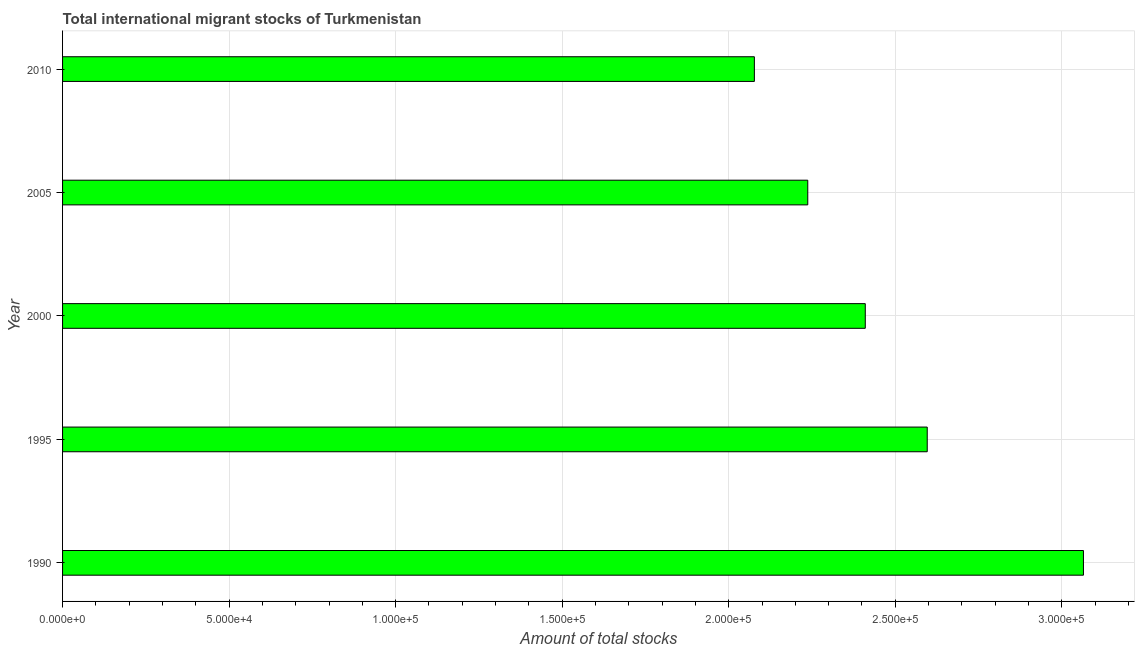Does the graph contain any zero values?
Give a very brief answer. No. What is the title of the graph?
Make the answer very short. Total international migrant stocks of Turkmenistan. What is the label or title of the X-axis?
Provide a short and direct response. Amount of total stocks. What is the label or title of the Y-axis?
Your answer should be compact. Year. What is the total number of international migrant stock in 2000?
Your answer should be very brief. 2.41e+05. Across all years, what is the maximum total number of international migrant stock?
Offer a terse response. 3.06e+05. Across all years, what is the minimum total number of international migrant stock?
Offer a terse response. 2.08e+05. What is the sum of the total number of international migrant stock?
Your answer should be very brief. 1.24e+06. What is the difference between the total number of international migrant stock in 1990 and 2000?
Offer a very short reply. 6.55e+04. What is the average total number of international migrant stock per year?
Your response must be concise. 2.48e+05. What is the median total number of international migrant stock?
Offer a terse response. 2.41e+05. What is the ratio of the total number of international migrant stock in 2000 to that in 2005?
Provide a short and direct response. 1.08. What is the difference between the highest and the second highest total number of international migrant stock?
Your answer should be very brief. 4.69e+04. Is the sum of the total number of international migrant stock in 2000 and 2005 greater than the maximum total number of international migrant stock across all years?
Your answer should be compact. Yes. What is the difference between the highest and the lowest total number of international migrant stock?
Ensure brevity in your answer.  9.88e+04. Are all the bars in the graph horizontal?
Keep it short and to the point. Yes. How many years are there in the graph?
Make the answer very short. 5. What is the difference between two consecutive major ticks on the X-axis?
Your response must be concise. 5.00e+04. Are the values on the major ticks of X-axis written in scientific E-notation?
Offer a very short reply. Yes. What is the Amount of total stocks in 1990?
Provide a succinct answer. 3.06e+05. What is the Amount of total stocks in 1995?
Provide a succinct answer. 2.60e+05. What is the Amount of total stocks of 2000?
Offer a very short reply. 2.41e+05. What is the Amount of total stocks of 2005?
Offer a very short reply. 2.24e+05. What is the Amount of total stocks of 2010?
Provide a succinct answer. 2.08e+05. What is the difference between the Amount of total stocks in 1990 and 1995?
Keep it short and to the point. 4.69e+04. What is the difference between the Amount of total stocks in 1990 and 2000?
Keep it short and to the point. 6.55e+04. What is the difference between the Amount of total stocks in 1990 and 2005?
Give a very brief answer. 8.28e+04. What is the difference between the Amount of total stocks in 1990 and 2010?
Offer a terse response. 9.88e+04. What is the difference between the Amount of total stocks in 1995 and 2000?
Offer a terse response. 1.86e+04. What is the difference between the Amount of total stocks in 1995 and 2005?
Offer a very short reply. 3.59e+04. What is the difference between the Amount of total stocks in 1995 and 2010?
Keep it short and to the point. 5.19e+04. What is the difference between the Amount of total stocks in 2000 and 2005?
Provide a succinct answer. 1.73e+04. What is the difference between the Amount of total stocks in 2000 and 2010?
Keep it short and to the point. 3.33e+04. What is the difference between the Amount of total stocks in 2005 and 2010?
Your answer should be very brief. 1.60e+04. What is the ratio of the Amount of total stocks in 1990 to that in 1995?
Ensure brevity in your answer.  1.18. What is the ratio of the Amount of total stocks in 1990 to that in 2000?
Ensure brevity in your answer.  1.27. What is the ratio of the Amount of total stocks in 1990 to that in 2005?
Your response must be concise. 1.37. What is the ratio of the Amount of total stocks in 1990 to that in 2010?
Make the answer very short. 1.48. What is the ratio of the Amount of total stocks in 1995 to that in 2000?
Provide a succinct answer. 1.08. What is the ratio of the Amount of total stocks in 1995 to that in 2005?
Provide a succinct answer. 1.16. What is the ratio of the Amount of total stocks in 2000 to that in 2005?
Provide a succinct answer. 1.08. What is the ratio of the Amount of total stocks in 2000 to that in 2010?
Offer a terse response. 1.16. What is the ratio of the Amount of total stocks in 2005 to that in 2010?
Your response must be concise. 1.08. 